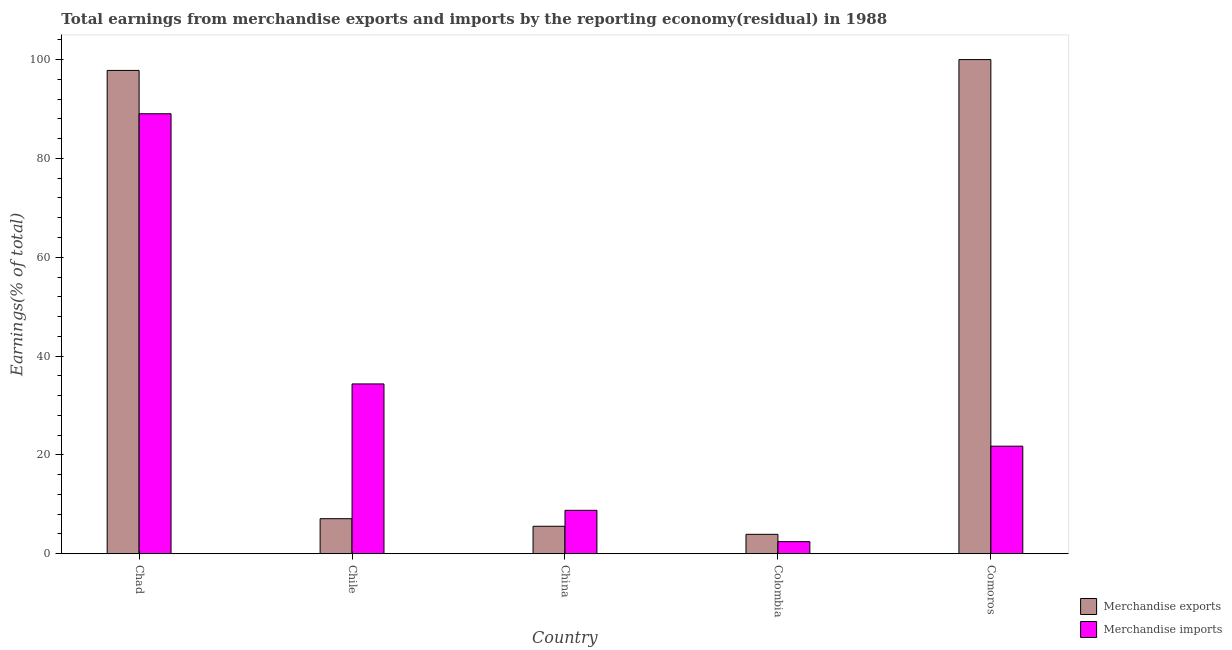How many groups of bars are there?
Offer a very short reply. 5. Are the number of bars on each tick of the X-axis equal?
Your response must be concise. Yes. What is the label of the 1st group of bars from the left?
Provide a short and direct response. Chad. What is the earnings from merchandise exports in Chile?
Offer a very short reply. 7.09. Across all countries, what is the maximum earnings from merchandise imports?
Offer a terse response. 89.04. Across all countries, what is the minimum earnings from merchandise imports?
Provide a succinct answer. 2.45. In which country was the earnings from merchandise imports maximum?
Provide a short and direct response. Chad. What is the total earnings from merchandise imports in the graph?
Provide a succinct answer. 156.4. What is the difference between the earnings from merchandise imports in Chad and that in Comoros?
Give a very brief answer. 67.27. What is the difference between the earnings from merchandise exports in China and the earnings from merchandise imports in Colombia?
Your answer should be very brief. 3.11. What is the average earnings from merchandise exports per country?
Keep it short and to the point. 42.88. What is the difference between the earnings from merchandise imports and earnings from merchandise exports in Comoros?
Your response must be concise. -78.23. What is the ratio of the earnings from merchandise exports in Chile to that in China?
Give a very brief answer. 1.28. Is the earnings from merchandise exports in China less than that in Comoros?
Offer a terse response. Yes. Is the difference between the earnings from merchandise exports in Chile and China greater than the difference between the earnings from merchandise imports in Chile and China?
Your answer should be compact. No. What is the difference between the highest and the second highest earnings from merchandise imports?
Ensure brevity in your answer.  54.67. What is the difference between the highest and the lowest earnings from merchandise exports?
Make the answer very short. 96.07. What does the 1st bar from the left in Chad represents?
Offer a very short reply. Merchandise exports. How many bars are there?
Keep it short and to the point. 10. Are all the bars in the graph horizontal?
Your answer should be very brief. No. How many countries are there in the graph?
Keep it short and to the point. 5. Are the values on the major ticks of Y-axis written in scientific E-notation?
Make the answer very short. No. Where does the legend appear in the graph?
Your answer should be very brief. Bottom right. How are the legend labels stacked?
Keep it short and to the point. Vertical. What is the title of the graph?
Give a very brief answer. Total earnings from merchandise exports and imports by the reporting economy(residual) in 1988. Does "Enforce a contract" appear as one of the legend labels in the graph?
Your answer should be very brief. No. What is the label or title of the X-axis?
Your answer should be very brief. Country. What is the label or title of the Y-axis?
Provide a short and direct response. Earnings(% of total). What is the Earnings(% of total) in Merchandise exports in Chad?
Keep it short and to the point. 97.81. What is the Earnings(% of total) in Merchandise imports in Chad?
Your response must be concise. 89.04. What is the Earnings(% of total) of Merchandise exports in Chile?
Keep it short and to the point. 7.09. What is the Earnings(% of total) in Merchandise imports in Chile?
Offer a terse response. 34.36. What is the Earnings(% of total) in Merchandise exports in China?
Your answer should be compact. 5.56. What is the Earnings(% of total) in Merchandise imports in China?
Offer a very short reply. 8.78. What is the Earnings(% of total) of Merchandise exports in Colombia?
Offer a terse response. 3.93. What is the Earnings(% of total) in Merchandise imports in Colombia?
Ensure brevity in your answer.  2.45. What is the Earnings(% of total) in Merchandise imports in Comoros?
Ensure brevity in your answer.  21.77. Across all countries, what is the maximum Earnings(% of total) in Merchandise imports?
Offer a terse response. 89.04. Across all countries, what is the minimum Earnings(% of total) in Merchandise exports?
Your answer should be very brief. 3.93. Across all countries, what is the minimum Earnings(% of total) in Merchandise imports?
Offer a very short reply. 2.45. What is the total Earnings(% of total) in Merchandise exports in the graph?
Provide a succinct answer. 214.38. What is the total Earnings(% of total) in Merchandise imports in the graph?
Give a very brief answer. 156.4. What is the difference between the Earnings(% of total) in Merchandise exports in Chad and that in Chile?
Give a very brief answer. 90.72. What is the difference between the Earnings(% of total) in Merchandise imports in Chad and that in Chile?
Provide a succinct answer. 54.67. What is the difference between the Earnings(% of total) in Merchandise exports in Chad and that in China?
Make the answer very short. 92.25. What is the difference between the Earnings(% of total) in Merchandise imports in Chad and that in China?
Your answer should be very brief. 80.25. What is the difference between the Earnings(% of total) in Merchandise exports in Chad and that in Colombia?
Ensure brevity in your answer.  93.88. What is the difference between the Earnings(% of total) of Merchandise imports in Chad and that in Colombia?
Your answer should be compact. 86.59. What is the difference between the Earnings(% of total) in Merchandise exports in Chad and that in Comoros?
Ensure brevity in your answer.  -2.19. What is the difference between the Earnings(% of total) in Merchandise imports in Chad and that in Comoros?
Ensure brevity in your answer.  67.27. What is the difference between the Earnings(% of total) in Merchandise exports in Chile and that in China?
Offer a terse response. 1.53. What is the difference between the Earnings(% of total) in Merchandise imports in Chile and that in China?
Make the answer very short. 25.58. What is the difference between the Earnings(% of total) of Merchandise exports in Chile and that in Colombia?
Your answer should be compact. 3.16. What is the difference between the Earnings(% of total) of Merchandise imports in Chile and that in Colombia?
Offer a very short reply. 31.92. What is the difference between the Earnings(% of total) in Merchandise exports in Chile and that in Comoros?
Offer a terse response. -92.91. What is the difference between the Earnings(% of total) in Merchandise imports in Chile and that in Comoros?
Give a very brief answer. 12.59. What is the difference between the Earnings(% of total) of Merchandise exports in China and that in Colombia?
Make the answer very short. 1.63. What is the difference between the Earnings(% of total) in Merchandise imports in China and that in Colombia?
Your answer should be compact. 6.34. What is the difference between the Earnings(% of total) of Merchandise exports in China and that in Comoros?
Provide a succinct answer. -94.44. What is the difference between the Earnings(% of total) of Merchandise imports in China and that in Comoros?
Provide a short and direct response. -12.99. What is the difference between the Earnings(% of total) of Merchandise exports in Colombia and that in Comoros?
Your answer should be compact. -96.07. What is the difference between the Earnings(% of total) of Merchandise imports in Colombia and that in Comoros?
Your answer should be compact. -19.32. What is the difference between the Earnings(% of total) in Merchandise exports in Chad and the Earnings(% of total) in Merchandise imports in Chile?
Make the answer very short. 63.44. What is the difference between the Earnings(% of total) of Merchandise exports in Chad and the Earnings(% of total) of Merchandise imports in China?
Provide a succinct answer. 89.02. What is the difference between the Earnings(% of total) in Merchandise exports in Chad and the Earnings(% of total) in Merchandise imports in Colombia?
Ensure brevity in your answer.  95.36. What is the difference between the Earnings(% of total) of Merchandise exports in Chad and the Earnings(% of total) of Merchandise imports in Comoros?
Your answer should be compact. 76.04. What is the difference between the Earnings(% of total) in Merchandise exports in Chile and the Earnings(% of total) in Merchandise imports in China?
Your response must be concise. -1.69. What is the difference between the Earnings(% of total) in Merchandise exports in Chile and the Earnings(% of total) in Merchandise imports in Colombia?
Provide a short and direct response. 4.64. What is the difference between the Earnings(% of total) of Merchandise exports in Chile and the Earnings(% of total) of Merchandise imports in Comoros?
Your answer should be very brief. -14.68. What is the difference between the Earnings(% of total) in Merchandise exports in China and the Earnings(% of total) in Merchandise imports in Colombia?
Give a very brief answer. 3.11. What is the difference between the Earnings(% of total) of Merchandise exports in China and the Earnings(% of total) of Merchandise imports in Comoros?
Your answer should be compact. -16.21. What is the difference between the Earnings(% of total) in Merchandise exports in Colombia and the Earnings(% of total) in Merchandise imports in Comoros?
Your answer should be very brief. -17.84. What is the average Earnings(% of total) of Merchandise exports per country?
Your answer should be compact. 42.88. What is the average Earnings(% of total) of Merchandise imports per country?
Offer a terse response. 31.28. What is the difference between the Earnings(% of total) of Merchandise exports and Earnings(% of total) of Merchandise imports in Chad?
Your answer should be compact. 8.77. What is the difference between the Earnings(% of total) in Merchandise exports and Earnings(% of total) in Merchandise imports in Chile?
Offer a very short reply. -27.27. What is the difference between the Earnings(% of total) in Merchandise exports and Earnings(% of total) in Merchandise imports in China?
Offer a terse response. -3.23. What is the difference between the Earnings(% of total) of Merchandise exports and Earnings(% of total) of Merchandise imports in Colombia?
Your answer should be compact. 1.48. What is the difference between the Earnings(% of total) of Merchandise exports and Earnings(% of total) of Merchandise imports in Comoros?
Make the answer very short. 78.23. What is the ratio of the Earnings(% of total) of Merchandise exports in Chad to that in Chile?
Make the answer very short. 13.8. What is the ratio of the Earnings(% of total) of Merchandise imports in Chad to that in Chile?
Keep it short and to the point. 2.59. What is the ratio of the Earnings(% of total) in Merchandise exports in Chad to that in China?
Offer a very short reply. 17.61. What is the ratio of the Earnings(% of total) of Merchandise imports in Chad to that in China?
Your response must be concise. 10.14. What is the ratio of the Earnings(% of total) in Merchandise exports in Chad to that in Colombia?
Offer a very short reply. 24.89. What is the ratio of the Earnings(% of total) of Merchandise imports in Chad to that in Colombia?
Provide a succinct answer. 36.41. What is the ratio of the Earnings(% of total) in Merchandise exports in Chad to that in Comoros?
Ensure brevity in your answer.  0.98. What is the ratio of the Earnings(% of total) in Merchandise imports in Chad to that in Comoros?
Provide a succinct answer. 4.09. What is the ratio of the Earnings(% of total) in Merchandise exports in Chile to that in China?
Provide a short and direct response. 1.28. What is the ratio of the Earnings(% of total) in Merchandise imports in Chile to that in China?
Ensure brevity in your answer.  3.91. What is the ratio of the Earnings(% of total) of Merchandise exports in Chile to that in Colombia?
Provide a succinct answer. 1.8. What is the ratio of the Earnings(% of total) of Merchandise imports in Chile to that in Colombia?
Your answer should be compact. 14.05. What is the ratio of the Earnings(% of total) of Merchandise exports in Chile to that in Comoros?
Provide a succinct answer. 0.07. What is the ratio of the Earnings(% of total) in Merchandise imports in Chile to that in Comoros?
Your answer should be very brief. 1.58. What is the ratio of the Earnings(% of total) in Merchandise exports in China to that in Colombia?
Your answer should be very brief. 1.41. What is the ratio of the Earnings(% of total) of Merchandise imports in China to that in Colombia?
Ensure brevity in your answer.  3.59. What is the ratio of the Earnings(% of total) of Merchandise exports in China to that in Comoros?
Keep it short and to the point. 0.06. What is the ratio of the Earnings(% of total) of Merchandise imports in China to that in Comoros?
Give a very brief answer. 0.4. What is the ratio of the Earnings(% of total) in Merchandise exports in Colombia to that in Comoros?
Provide a succinct answer. 0.04. What is the ratio of the Earnings(% of total) of Merchandise imports in Colombia to that in Comoros?
Keep it short and to the point. 0.11. What is the difference between the highest and the second highest Earnings(% of total) in Merchandise exports?
Your response must be concise. 2.19. What is the difference between the highest and the second highest Earnings(% of total) of Merchandise imports?
Provide a short and direct response. 54.67. What is the difference between the highest and the lowest Earnings(% of total) of Merchandise exports?
Your answer should be compact. 96.07. What is the difference between the highest and the lowest Earnings(% of total) in Merchandise imports?
Your response must be concise. 86.59. 